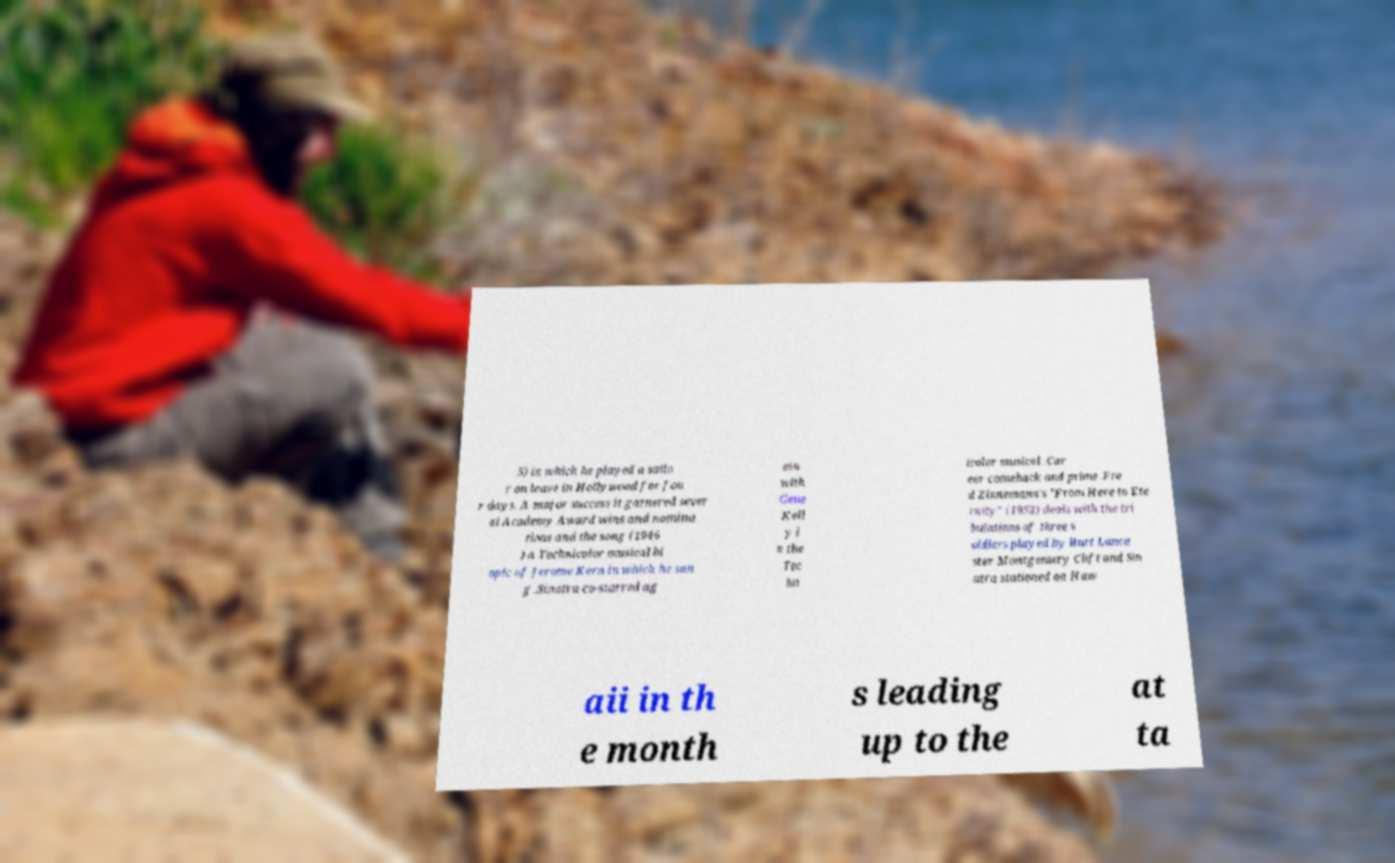Could you extract and type out the text from this image? 5) in which he played a sailo r on leave in Hollywood for fou r days. A major success it garnered sever al Academy Award wins and nomina tions and the song (1946 ) a Technicolor musical bi opic of Jerome Kern in which he san g .Sinatra co-starred ag ain with Gene Kell y i n the Tec hn icolor musical .Car eer comeback and prime .Fre d Zinnemann's "From Here to Ete rnity" (1953) deals with the tri bulations of three s oldiers played by Burt Lanca ster Montgomery Clift and Sin atra stationed on Haw aii in th e month s leading up to the at ta 